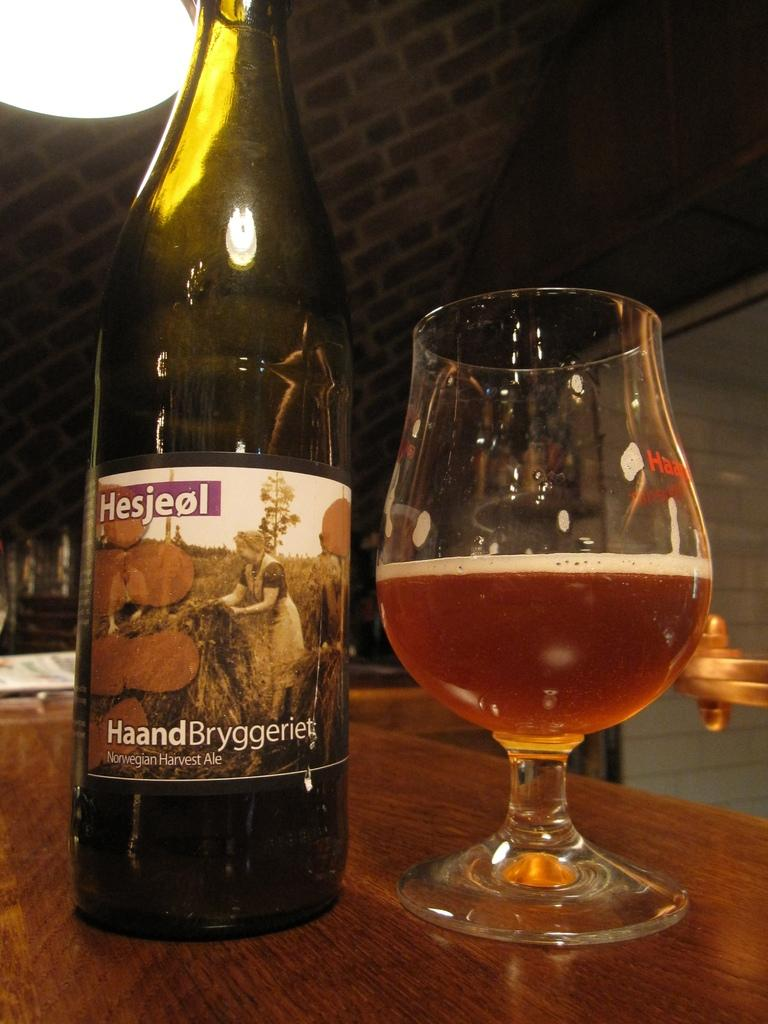<image>
Offer a succinct explanation of the picture presented. A bottle of Hesjeol HaandBryggeriet sits next to a half full glass of beer. 